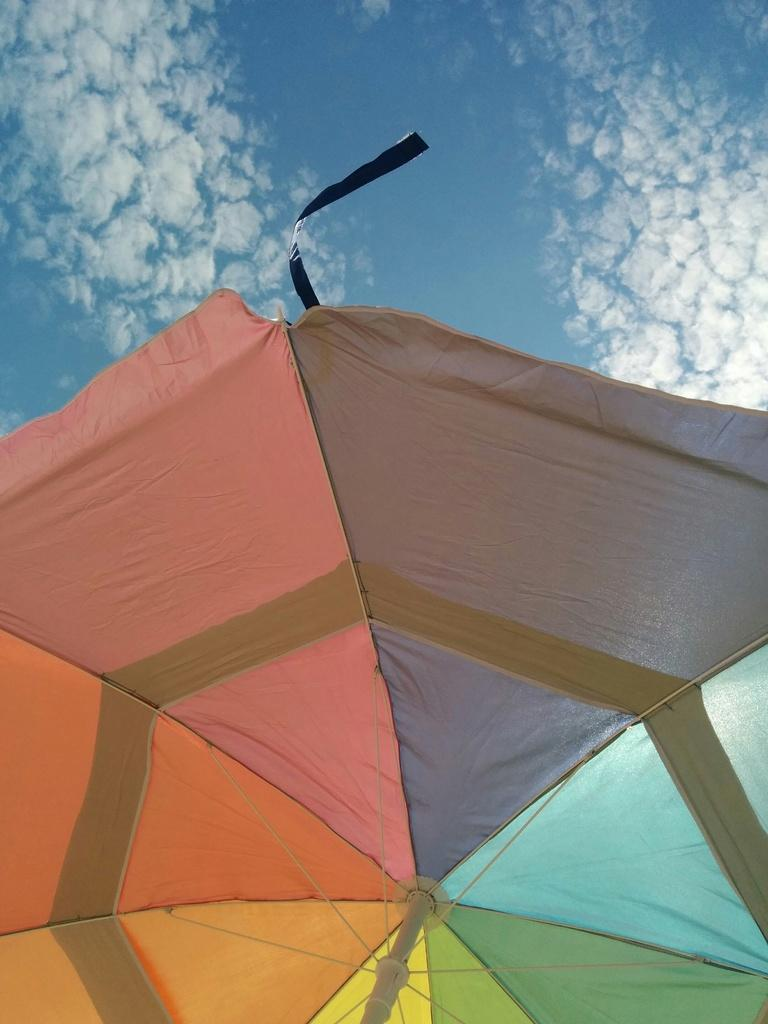What object can be seen in the image? There is a parasol in the image. What can be seen in the background of the image? There is sky visible in the background of the image. What alley is the actor walking through in the image? There is no alley or actor present in the image; it only features a parasol and sky. 